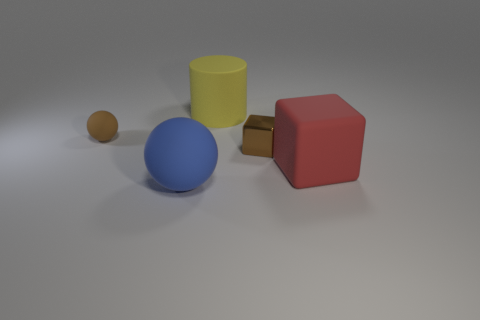Is there anything else that is the same shape as the yellow rubber thing?
Make the answer very short. No. How many other objects are the same size as the red matte object?
Keep it short and to the point. 2. There is a blue matte thing; is it the same shape as the tiny object to the left of the large yellow matte cylinder?
Your answer should be very brief. Yes. What number of rubber things are big balls or large red things?
Offer a very short reply. 2. Are there any other small cubes that have the same color as the tiny block?
Give a very brief answer. No. Are there any brown rubber spheres?
Offer a terse response. Yes. Is the shape of the big blue matte object the same as the tiny rubber object?
Offer a terse response. Yes. How many small things are yellow matte spheres or blue things?
Give a very brief answer. 0. The large rubber cylinder has what color?
Your answer should be compact. Yellow. What is the shape of the big matte object that is behind the brown thing that is to the left of the large blue rubber thing?
Keep it short and to the point. Cylinder. 